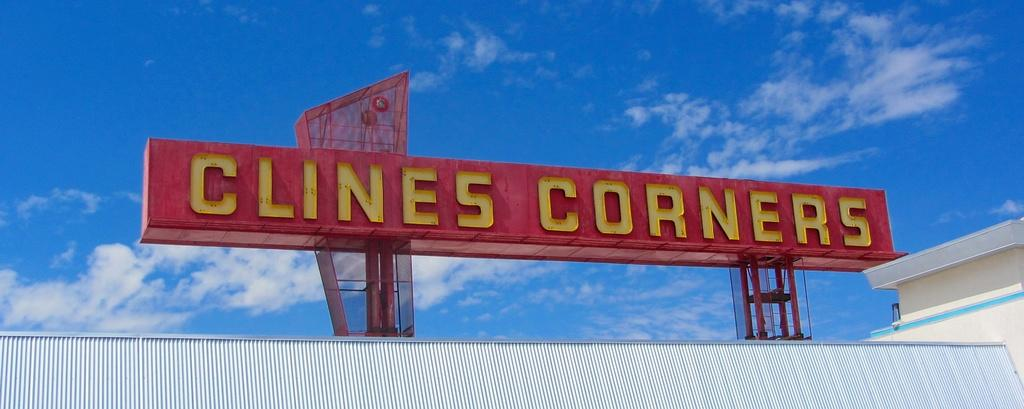<image>
Share a concise interpretation of the image provided. A sign outside a store called Clines Corners. 